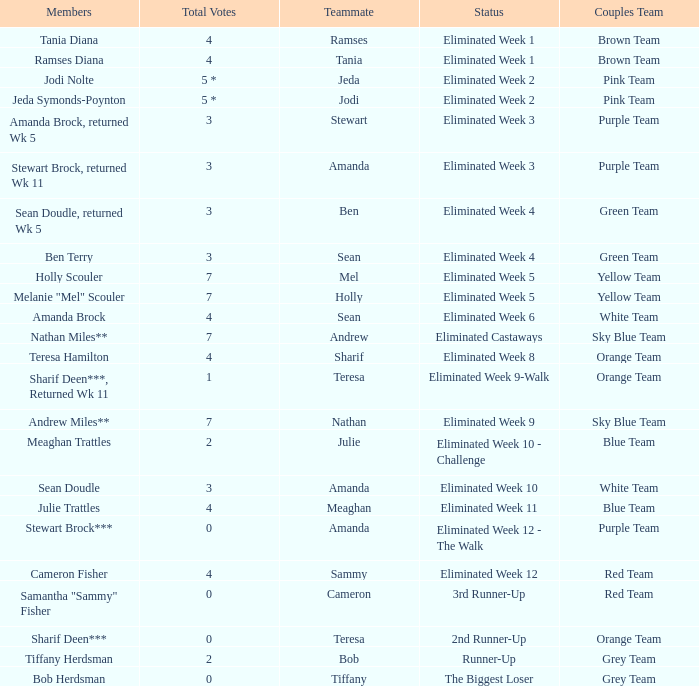What were Holly Scouler's total votes? 7.0. 